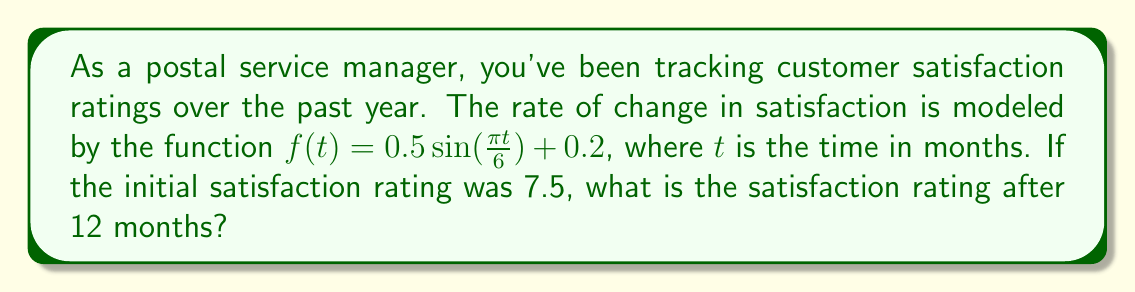What is the answer to this math problem? To solve this problem, we need to use an integral equation. The steps are as follows:

1) The rate of change in satisfaction is given by $f(t) = 0.5\sin(\frac{\pi t}{6}) + 0.2$

2) To find the total change in satisfaction over 12 months, we need to integrate this function from 0 to 12:

   $$\int_0^{12} (0.5\sin(\frac{\pi t}{6}) + 0.2) dt$$

3) Let's solve this integral:
   
   $$\int_0^{12} 0.5\sin(\frac{\pi t}{6}) dt + \int_0^{12} 0.2 dt$$

4) For the first part:
   
   $$-0.5 \cdot \frac{6}{\pi} \cos(\frac{\pi t}{6}) \Big|_0^{12} = -\frac{3}{\pi} [\cos(2\pi) - \cos(0)] = 0$$

5) For the second part:
   
   $$0.2t \Big|_0^{12} = 0.2 \cdot 12 = 2.4$$

6) The total change in satisfaction is therefore 2.4

7) Since the initial satisfaction was 7.5, the final satisfaction after 12 months is:

   $$7.5 + 2.4 = 9.9$$
Answer: 9.9 